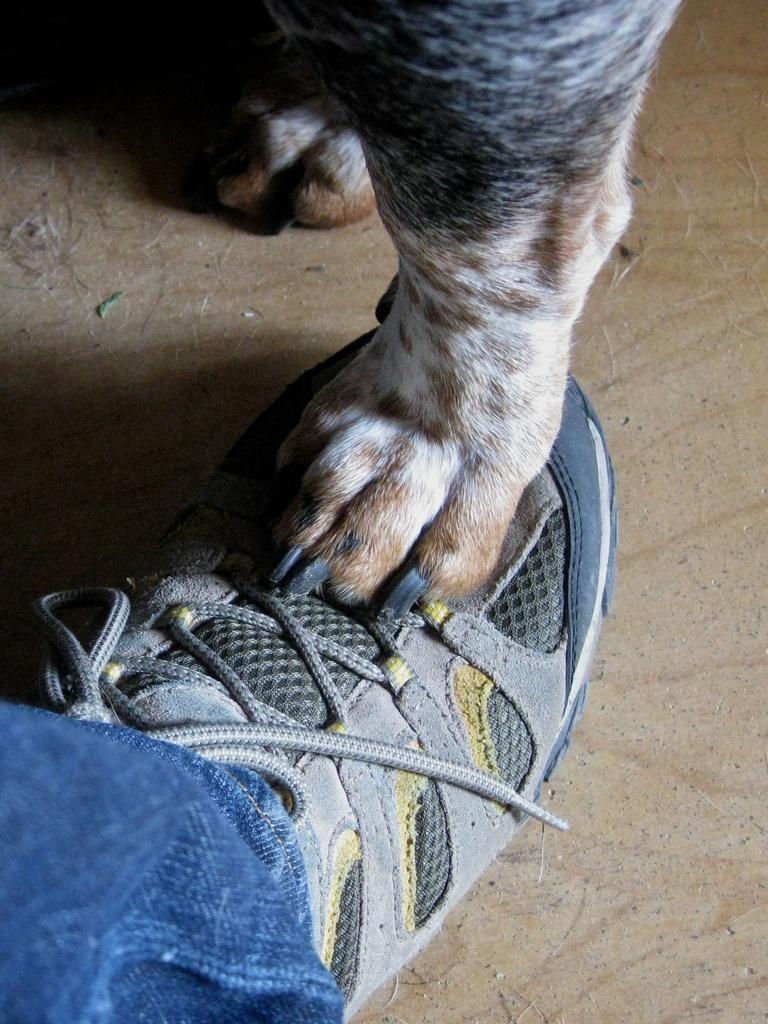Could you give a brief overview of what you see in this image? In this image I can see a shoe and on it I can see leg of an animal. On the bottom left corner of this image I can see blue colour jeans. 